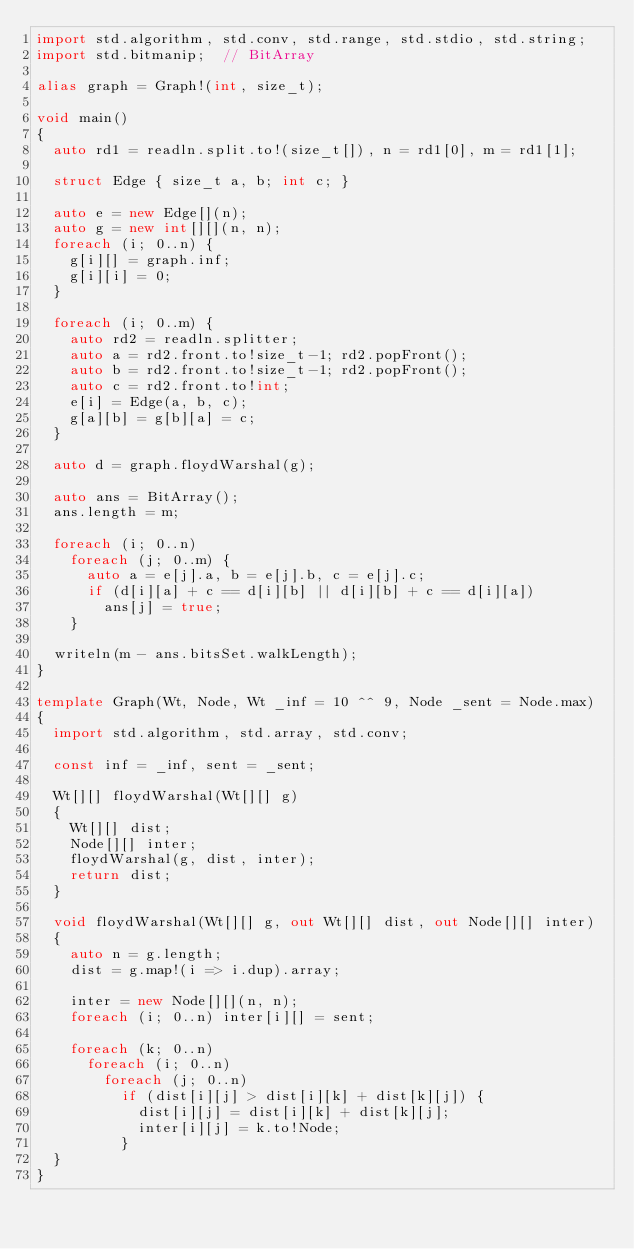Convert code to text. <code><loc_0><loc_0><loc_500><loc_500><_D_>import std.algorithm, std.conv, std.range, std.stdio, std.string;
import std.bitmanip;  // BitArray

alias graph = Graph!(int, size_t);

void main()
{
  auto rd1 = readln.split.to!(size_t[]), n = rd1[0], m = rd1[1];

  struct Edge { size_t a, b; int c; }

  auto e = new Edge[](n);
  auto g = new int[][](n, n);
  foreach (i; 0..n) {
    g[i][] = graph.inf;
    g[i][i] = 0;
  }

  foreach (i; 0..m) {
    auto rd2 = readln.splitter;
    auto a = rd2.front.to!size_t-1; rd2.popFront();
    auto b = rd2.front.to!size_t-1; rd2.popFront();
    auto c = rd2.front.to!int;
    e[i] = Edge(a, b, c);
    g[a][b] = g[b][a] = c;
  }

  auto d = graph.floydWarshal(g);

  auto ans = BitArray();
  ans.length = m;

  foreach (i; 0..n)
    foreach (j; 0..m) {
      auto a = e[j].a, b = e[j].b, c = e[j].c;
      if (d[i][a] + c == d[i][b] || d[i][b] + c == d[i][a])
        ans[j] = true;
    }

  writeln(m - ans.bitsSet.walkLength);
}

template Graph(Wt, Node, Wt _inf = 10 ^^ 9, Node _sent = Node.max)
{
  import std.algorithm, std.array, std.conv;

  const inf = _inf, sent = _sent;

  Wt[][] floydWarshal(Wt[][] g)
  {
    Wt[][] dist;
    Node[][] inter;
    floydWarshal(g, dist, inter);
    return dist;
  }

  void floydWarshal(Wt[][] g, out Wt[][] dist, out Node[][] inter)
  {
    auto n = g.length;
    dist = g.map!(i => i.dup).array;

    inter = new Node[][](n, n);
    foreach (i; 0..n) inter[i][] = sent;

    foreach (k; 0..n)
      foreach (i; 0..n)
        foreach (j; 0..n)
          if (dist[i][j] > dist[i][k] + dist[k][j]) {
            dist[i][j] = dist[i][k] + dist[k][j];
            inter[i][j] = k.to!Node;
          }
  }
}
</code> 